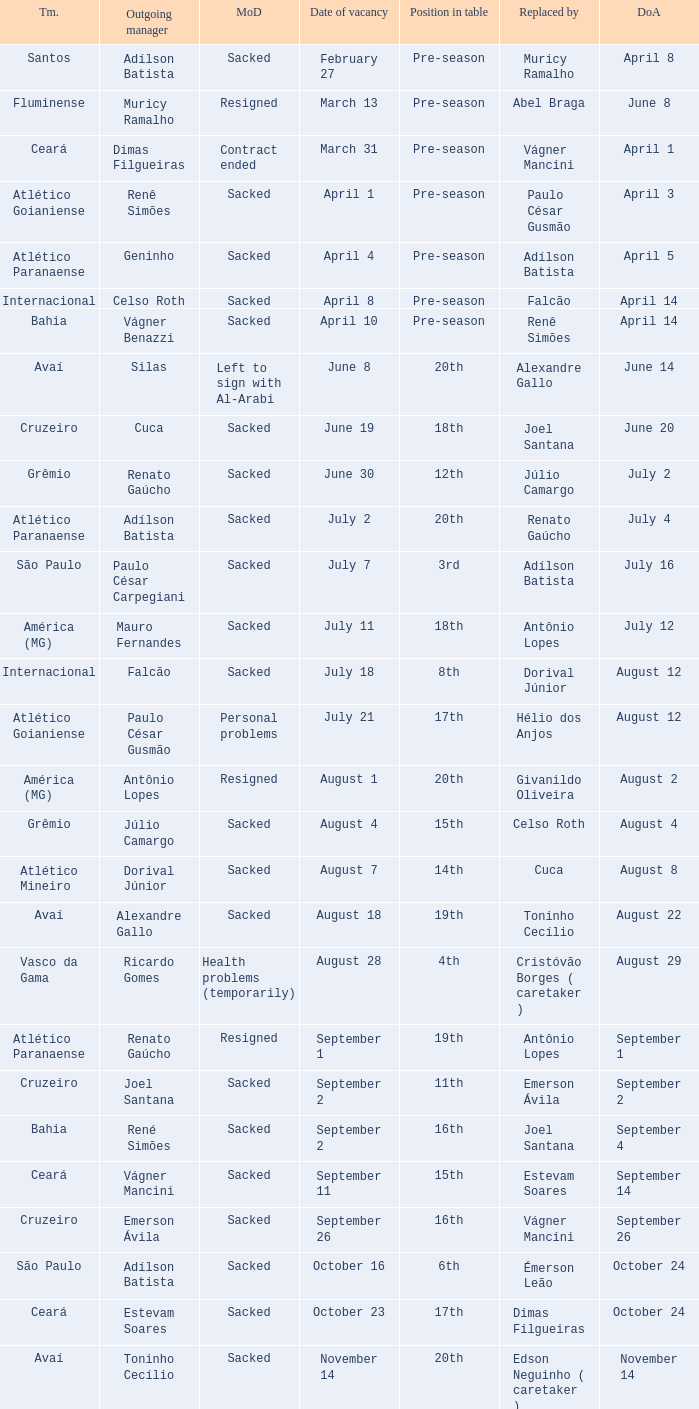How many times did Silas leave as a team manager? 1.0. 